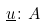Convert formula to latex. <formula><loc_0><loc_0><loc_500><loc_500>\underline { u } \colon A</formula> 